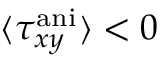Convert formula to latex. <formula><loc_0><loc_0><loc_500><loc_500>\langle \tau _ { x y } ^ { a n i } \rangle < 0</formula> 